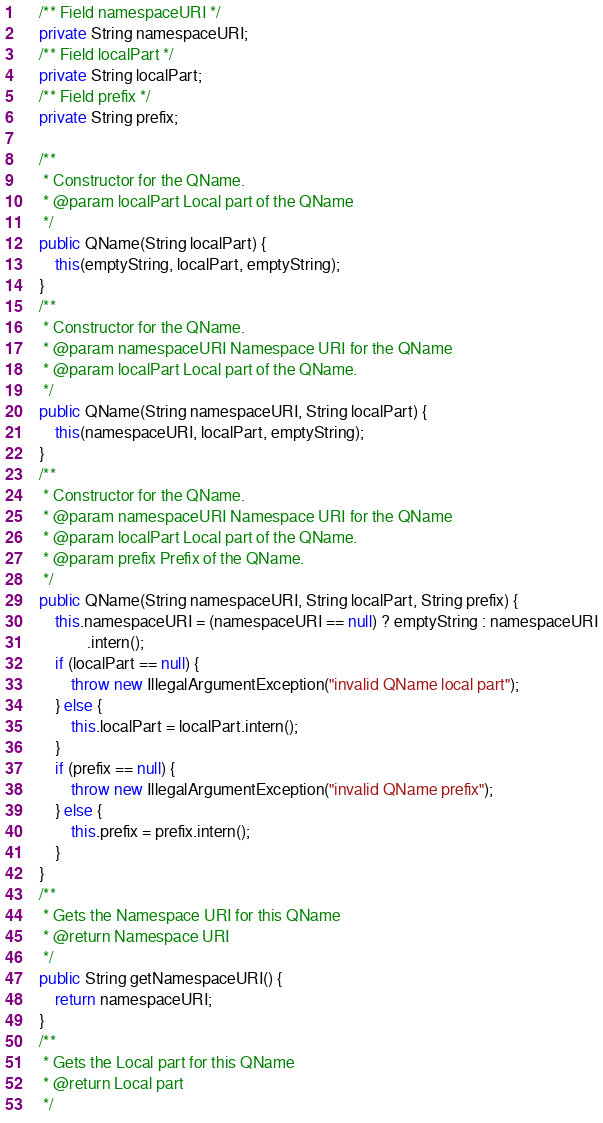Convert code to text. <code><loc_0><loc_0><loc_500><loc_500><_Java_>	/** Field namespaceURI */
	private String namespaceURI;
	/** Field localPart */
	private String localPart;
	/** Field prefix */
	private String prefix;

	/**
	 * Constructor for the QName.
	 * @param localPart Local part of the QName
	 */
	public QName(String localPart) {
		this(emptyString, localPart, emptyString);
	}
	/**
	 * Constructor for the QName.
	 * @param namespaceURI Namespace URI for the QName
	 * @param localPart Local part of the QName.
	 */
	public QName(String namespaceURI, String localPart) {
		this(namespaceURI, localPart, emptyString);
	}
	/**
	 * Constructor for the QName.
	 * @param namespaceURI Namespace URI for the QName
	 * @param localPart Local part of the QName.
	 * @param prefix Prefix of the QName.
	 */
	public QName(String namespaceURI, String localPart, String prefix) {
		this.namespaceURI = (namespaceURI == null) ? emptyString : namespaceURI
				.intern();
		if (localPart == null) {
			throw new IllegalArgumentException("invalid QName local part");
		} else {
			this.localPart = localPart.intern();
		}
		if (prefix == null) {
			throw new IllegalArgumentException("invalid QName prefix");
		} else {
			this.prefix = prefix.intern();
		}
	}
	/**
	 * Gets the Namespace URI for this QName
	 * @return Namespace URI
	 */
	public String getNamespaceURI() {
		return namespaceURI;
	}
	/**
	 * Gets the Local part for this QName
	 * @return Local part
	 */</code> 